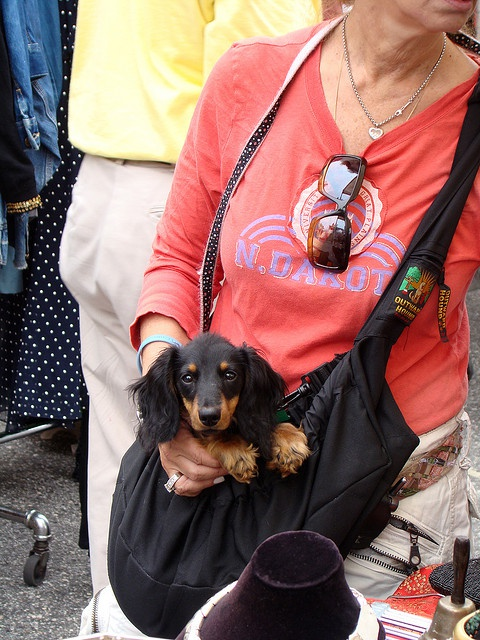Describe the objects in this image and their specific colors. I can see people in black, salmon, and brown tones, people in black, ivory, khaki, and pink tones, handbag in black, gray, and maroon tones, and dog in black, gray, and maroon tones in this image. 